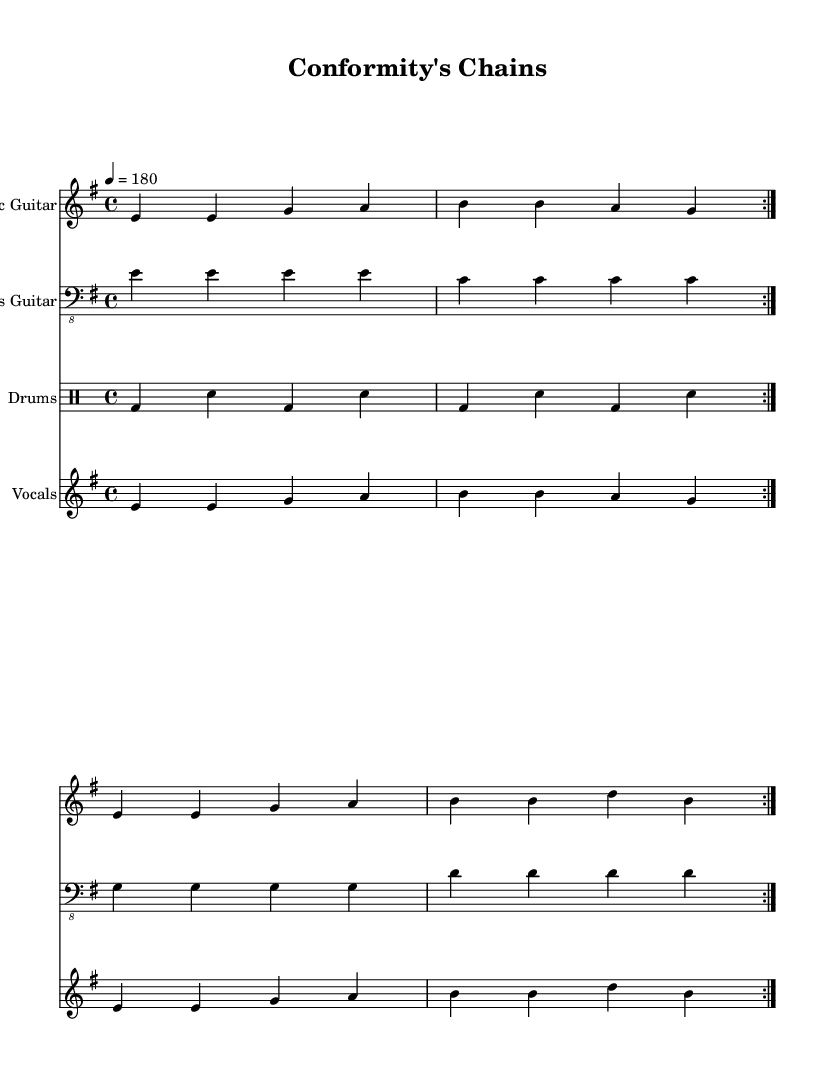What is the key signature of this music? The key signature is E minor, identified by one sharp (F#) on the staff.
Answer: E minor What is the time signature of this music? The time signature can be found at the beginning of the score and it is 4/4, meaning there are four beats per measure.
Answer: 4/4 What is the tempo marking for this piece? The tempo marking is located at the start of the score, which indicates that the piece should be played at a speed of 180 beats per minute.
Answer: 180 How many repetitions of the main section are indicated in the score? The score indicates a repeat sign ("volta") which suggests the main section is to be repeated twice.
Answer: 2 What is the main lyrical theme discussed in the verse? The main theme discussed in the lyrics is societal expectations and the constraints of conformity, emphasizing feelings of being trapped.
Answer: Expectations and conformity What musical instrument plays the bass line? The bass line is played by the "Bass Guitar," as specified in the score under the instrument name.
Answer: Bass Guitar What message does the chorus convey about the artist's freedom? The chorus expresses a desire to break free from societal rules and create one’s own reality, highlighting themes of independence and self-expression.
Answer: Break free and create 